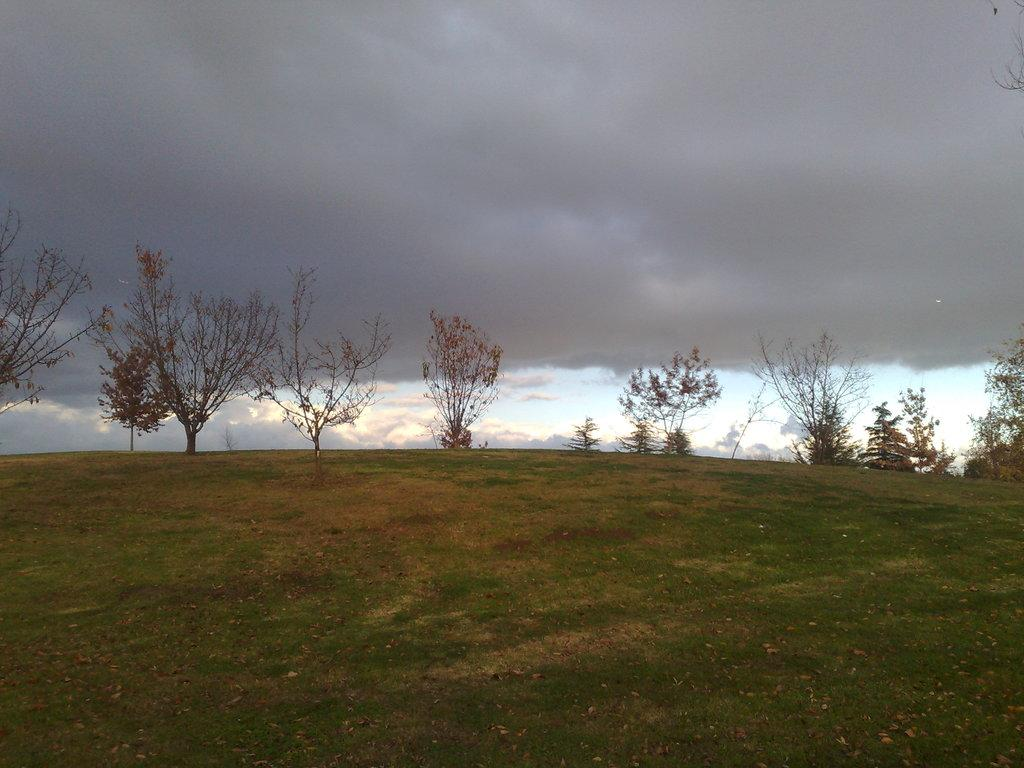What type of vegetation can be seen in the image? There is grass, plants, and trees in the image. What can be seen in the background of the image? The sky is visible in the background of the image. What is present in the sky? There are clouds in the sky. What is the outcome of the argument between the trees in the image? There is no argument present in the image; it features grass, plants, trees, and a sky with clouds. What is the taste of the baseball in the image? There is no baseball present in the image; it features grass, plants, trees, and a sky with clouds. 